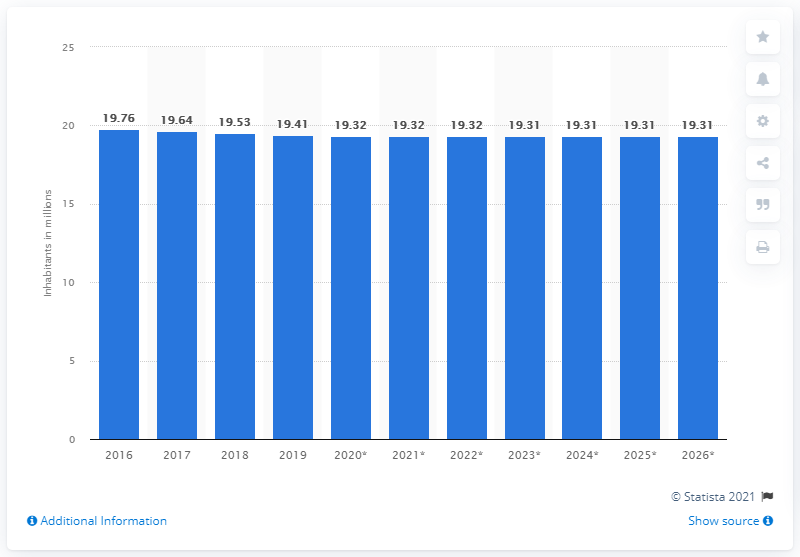List a handful of essential elements in this visual. In 2019, the population of Romania was approximately 19.31 million people. 